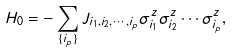<formula> <loc_0><loc_0><loc_500><loc_500>H _ { 0 } = - \sum _ { \{ i _ { p } \} } J _ { i _ { 1 } , i _ { 2 } , \cdots , i _ { p } } \sigma _ { i _ { 1 } } ^ { z } \sigma _ { i _ { 2 } } ^ { z } \cdots \sigma _ { i _ { p } } ^ { z } ,</formula> 